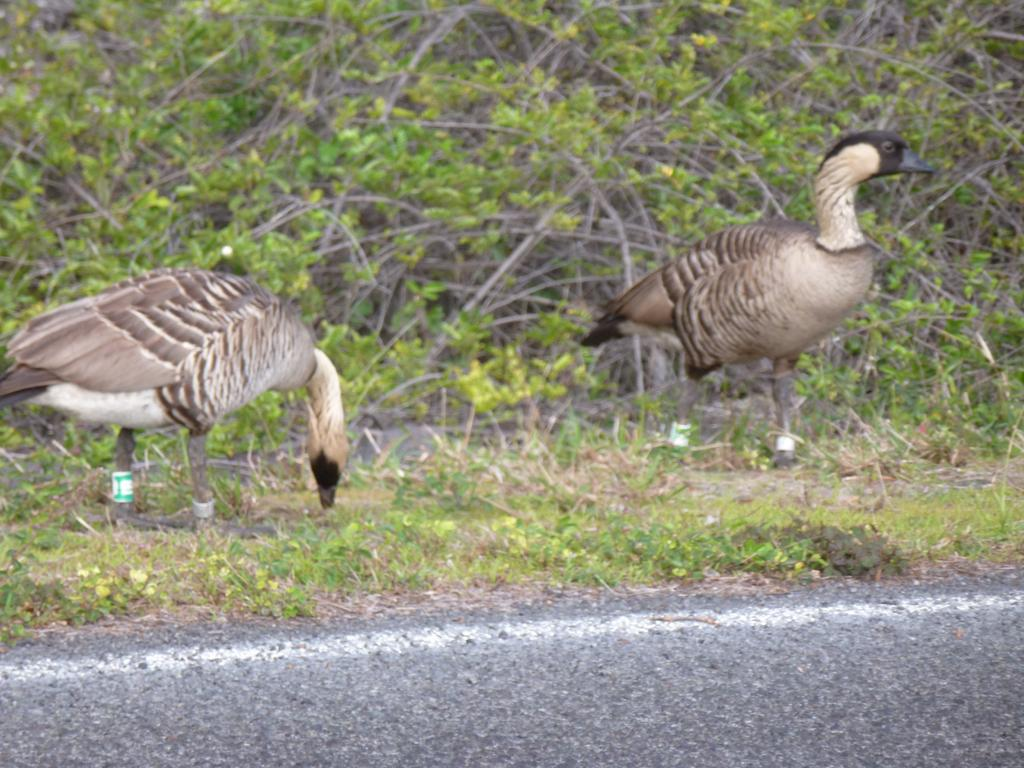How many birds are present in the image? There are two birds in the image. What colors can be seen on the birds? The birds are black, brown, and cream in color. Where are the birds located in the image? The birds are standing on the ground. What type of surface can be seen in the image? There is a road visible in the image. What type of vegetation is present in the image? There is grass in the image. What can be seen in the background of the image? There are plants in the background of the image. How many children are playing with the birds in the image? There are no children present in the image; it only features two birds. What color are the eyes of the birds in the image? The provided facts do not mention the color of the birds' eyes, so we cannot determine that information from the image. 